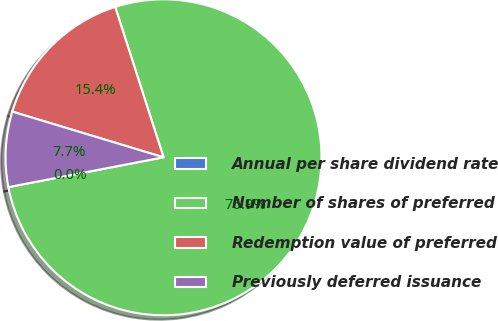Convert chart to OTSL. <chart><loc_0><loc_0><loc_500><loc_500><pie_chart><fcel>Annual per share dividend rate<fcel>Number of shares of preferred<fcel>Redemption value of preferred<fcel>Previously deferred issuance<nl><fcel>0.0%<fcel>76.92%<fcel>15.38%<fcel>7.69%<nl></chart> 